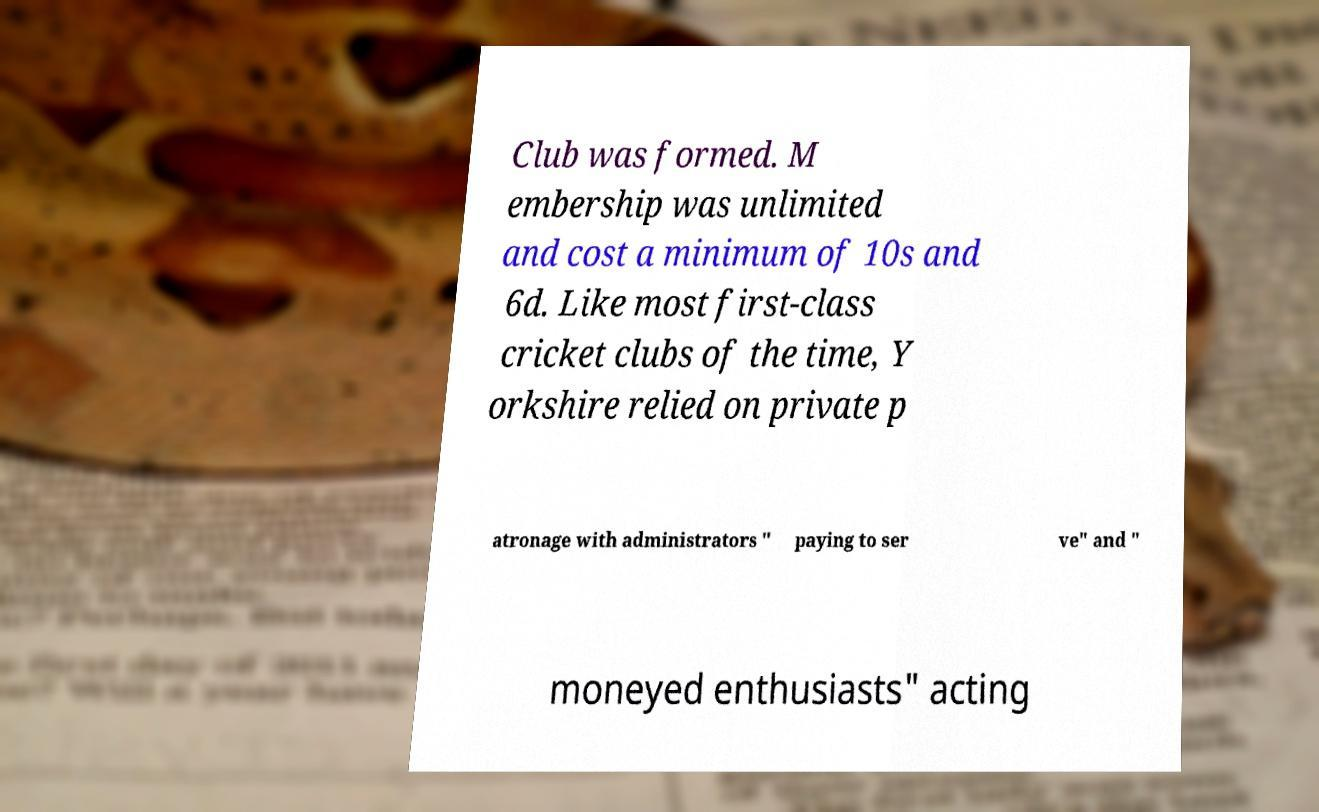For documentation purposes, I need the text within this image transcribed. Could you provide that? Club was formed. M embership was unlimited and cost a minimum of 10s and 6d. Like most first-class cricket clubs of the time, Y orkshire relied on private p atronage with administrators " paying to ser ve" and " moneyed enthusiasts" acting 